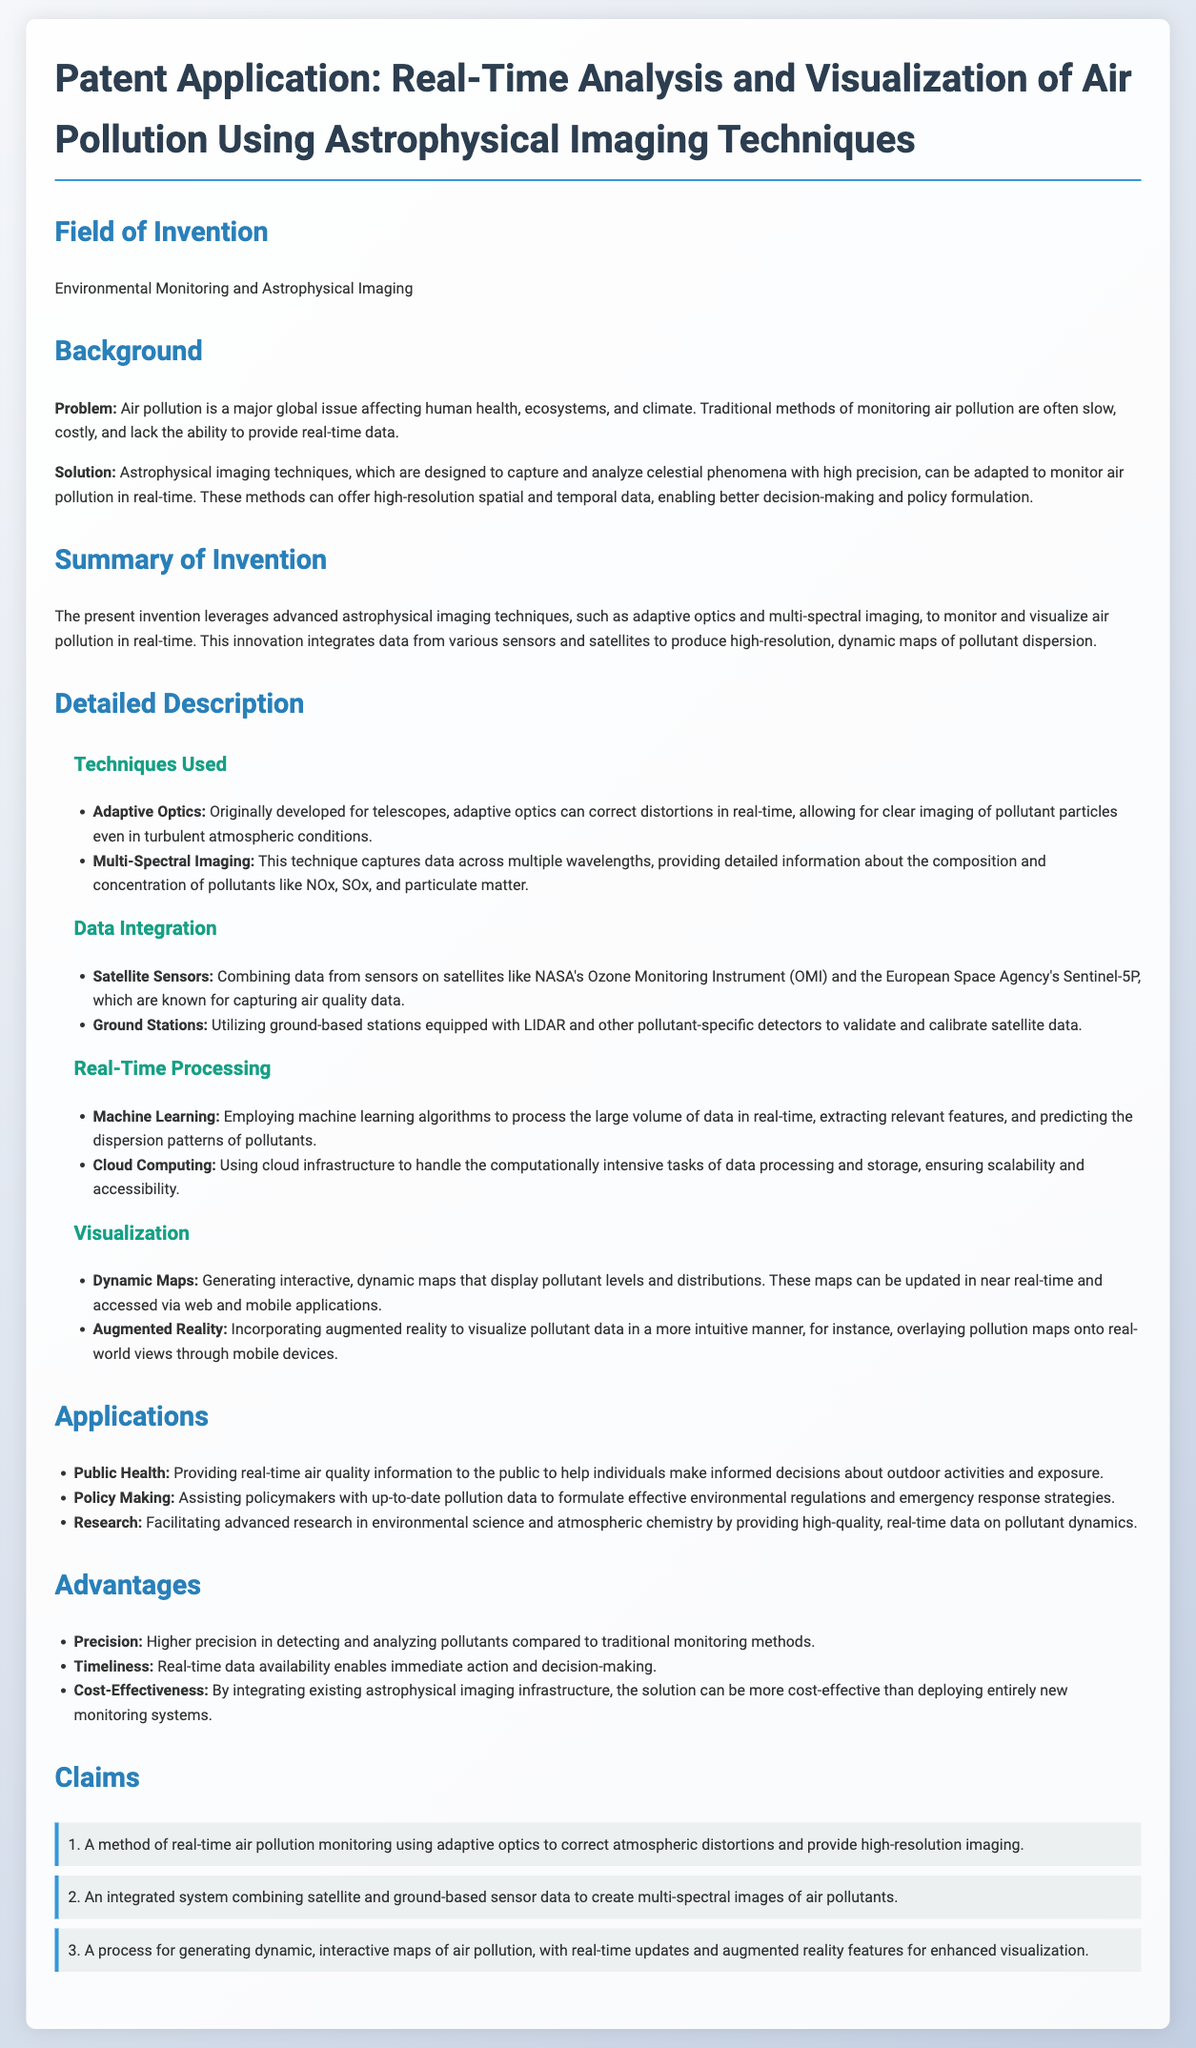What is the field of invention? The field of invention is explicitly stated in the document as "Environmental Monitoring and Astrophysical Imaging."
Answer: Environmental Monitoring and Astrophysical Imaging What are the main techniques used in this patent? The document lists the techniques used, which include "Adaptive Optics" and "Multi-Spectral Imaging."
Answer: Adaptive Optics and Multi-Spectral Imaging Which satellite instrument is mentioned for capturing air quality data? The patent identifies specific satellite instruments, one of which is "NASA's Ozone Monitoring Instrument (OMI)."
Answer: NASA's Ozone Monitoring Instrument (OMI) What does the invention provide for public health? The application specifies a benefit to public health as "real-time air quality information."
Answer: Real-time air quality information Which processing method is utilized for real-time data analysis? The document mentions "Machine Learning" as a key method for processing data in real time.
Answer: Machine Learning What type of maps does the invention generate? The patent describes generating "dynamic, interactive maps" for visualization of air pollution.
Answer: Dynamic, interactive maps What advantage does this invention offer compared to traditional methods? The invention claims to provide "higher precision in detecting and analyzing pollutants" as an advantage.
Answer: Higher precision in detecting and analyzing pollutants What is the claim number that refers to the use of adaptive optics? The claim referring to adaptive optics is the first one, as indicated in the claims section.
Answer: 1 How does the invention assist policymakers? The document states that the invention assists policymakers by providing "up-to-date pollution data."
Answer: Up-to-date pollution data 